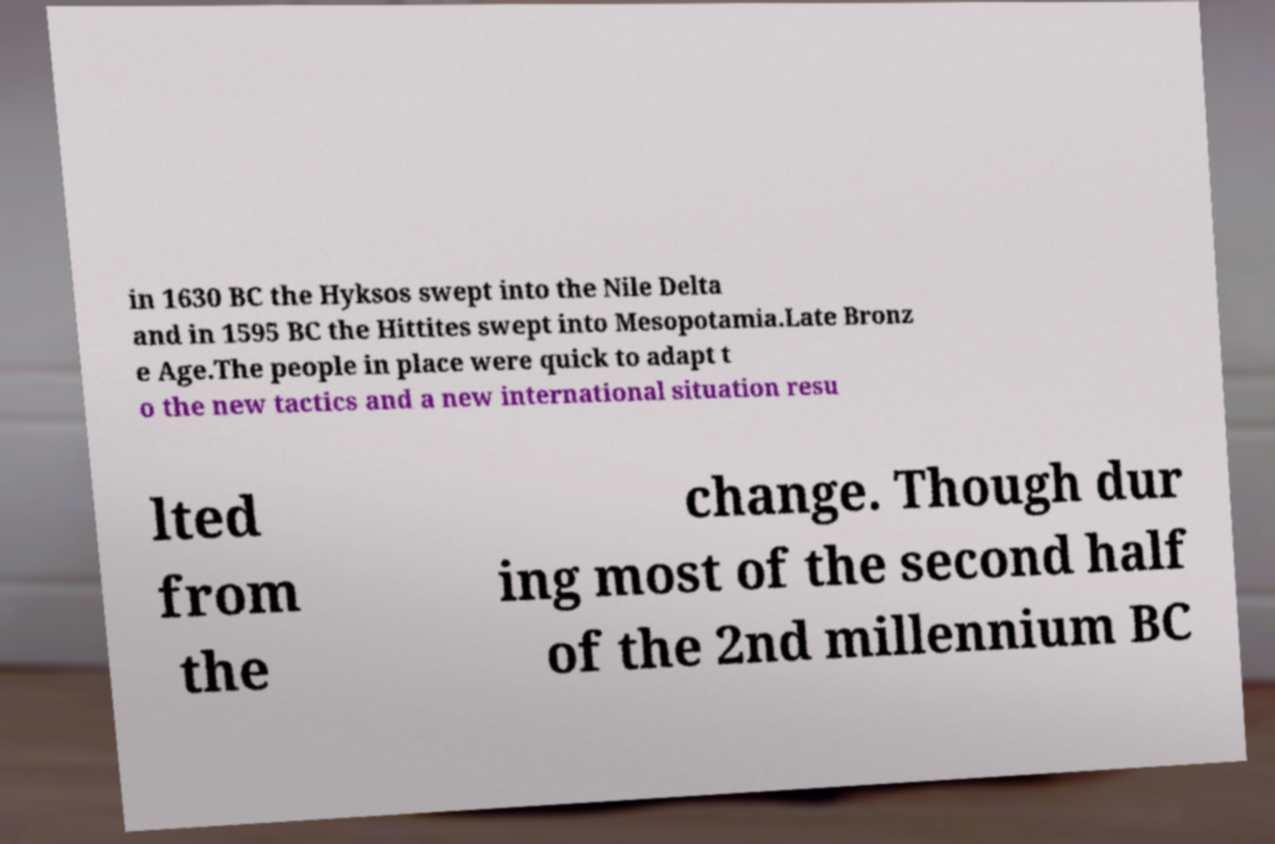Can you read and provide the text displayed in the image?This photo seems to have some interesting text. Can you extract and type it out for me? in 1630 BC the Hyksos swept into the Nile Delta and in 1595 BC the Hittites swept into Mesopotamia.Late Bronz e Age.The people in place were quick to adapt t o the new tactics and a new international situation resu lted from the change. Though dur ing most of the second half of the 2nd millennium BC 